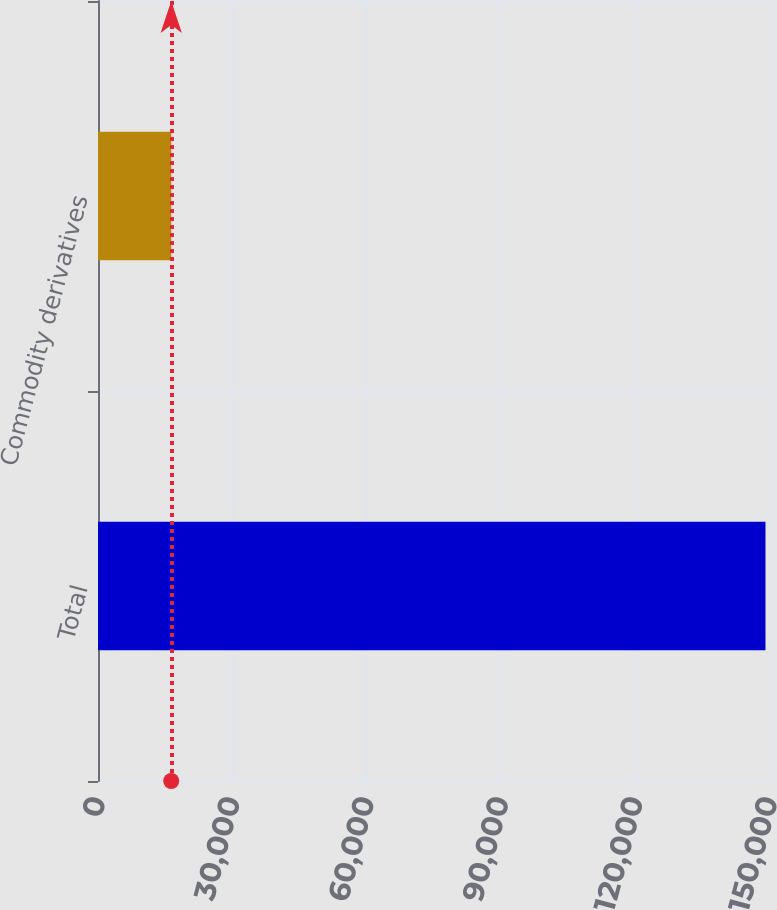<chart> <loc_0><loc_0><loc_500><loc_500><bar_chart><fcel>Total<fcel>Commodity derivatives<nl><fcel>148988<fcel>16344<nl></chart> 